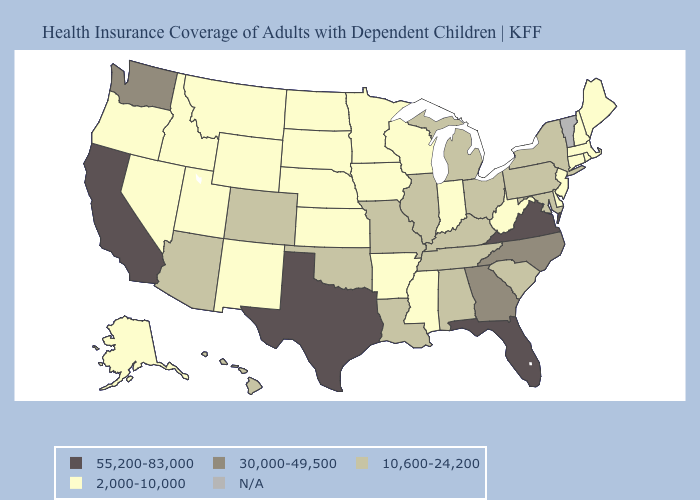Among the states that border Utah , does Wyoming have the lowest value?
Concise answer only. Yes. What is the lowest value in states that border New York?
Answer briefly. 2,000-10,000. What is the lowest value in the West?
Keep it brief. 2,000-10,000. What is the highest value in states that border New Mexico?
Write a very short answer. 55,200-83,000. What is the highest value in the USA?
Concise answer only. 55,200-83,000. Does South Dakota have the highest value in the MidWest?
Be succinct. No. Name the states that have a value in the range 10,600-24,200?
Be succinct. Alabama, Arizona, Colorado, Hawaii, Illinois, Kentucky, Louisiana, Maryland, Michigan, Missouri, New York, Ohio, Oklahoma, Pennsylvania, South Carolina, Tennessee. Does the map have missing data?
Be succinct. Yes. What is the value of Florida?
Quick response, please. 55,200-83,000. How many symbols are there in the legend?
Be succinct. 5. Name the states that have a value in the range 2,000-10,000?
Answer briefly. Alaska, Arkansas, Connecticut, Delaware, Idaho, Indiana, Iowa, Kansas, Maine, Massachusetts, Minnesota, Mississippi, Montana, Nebraska, Nevada, New Hampshire, New Jersey, New Mexico, North Dakota, Oregon, Rhode Island, South Dakota, Utah, West Virginia, Wisconsin, Wyoming. Does Pennsylvania have the lowest value in the Northeast?
Concise answer only. No. Name the states that have a value in the range 10,600-24,200?
Quick response, please. Alabama, Arizona, Colorado, Hawaii, Illinois, Kentucky, Louisiana, Maryland, Michigan, Missouri, New York, Ohio, Oklahoma, Pennsylvania, South Carolina, Tennessee. Which states have the lowest value in the USA?
Give a very brief answer. Alaska, Arkansas, Connecticut, Delaware, Idaho, Indiana, Iowa, Kansas, Maine, Massachusetts, Minnesota, Mississippi, Montana, Nebraska, Nevada, New Hampshire, New Jersey, New Mexico, North Dakota, Oregon, Rhode Island, South Dakota, Utah, West Virginia, Wisconsin, Wyoming. 